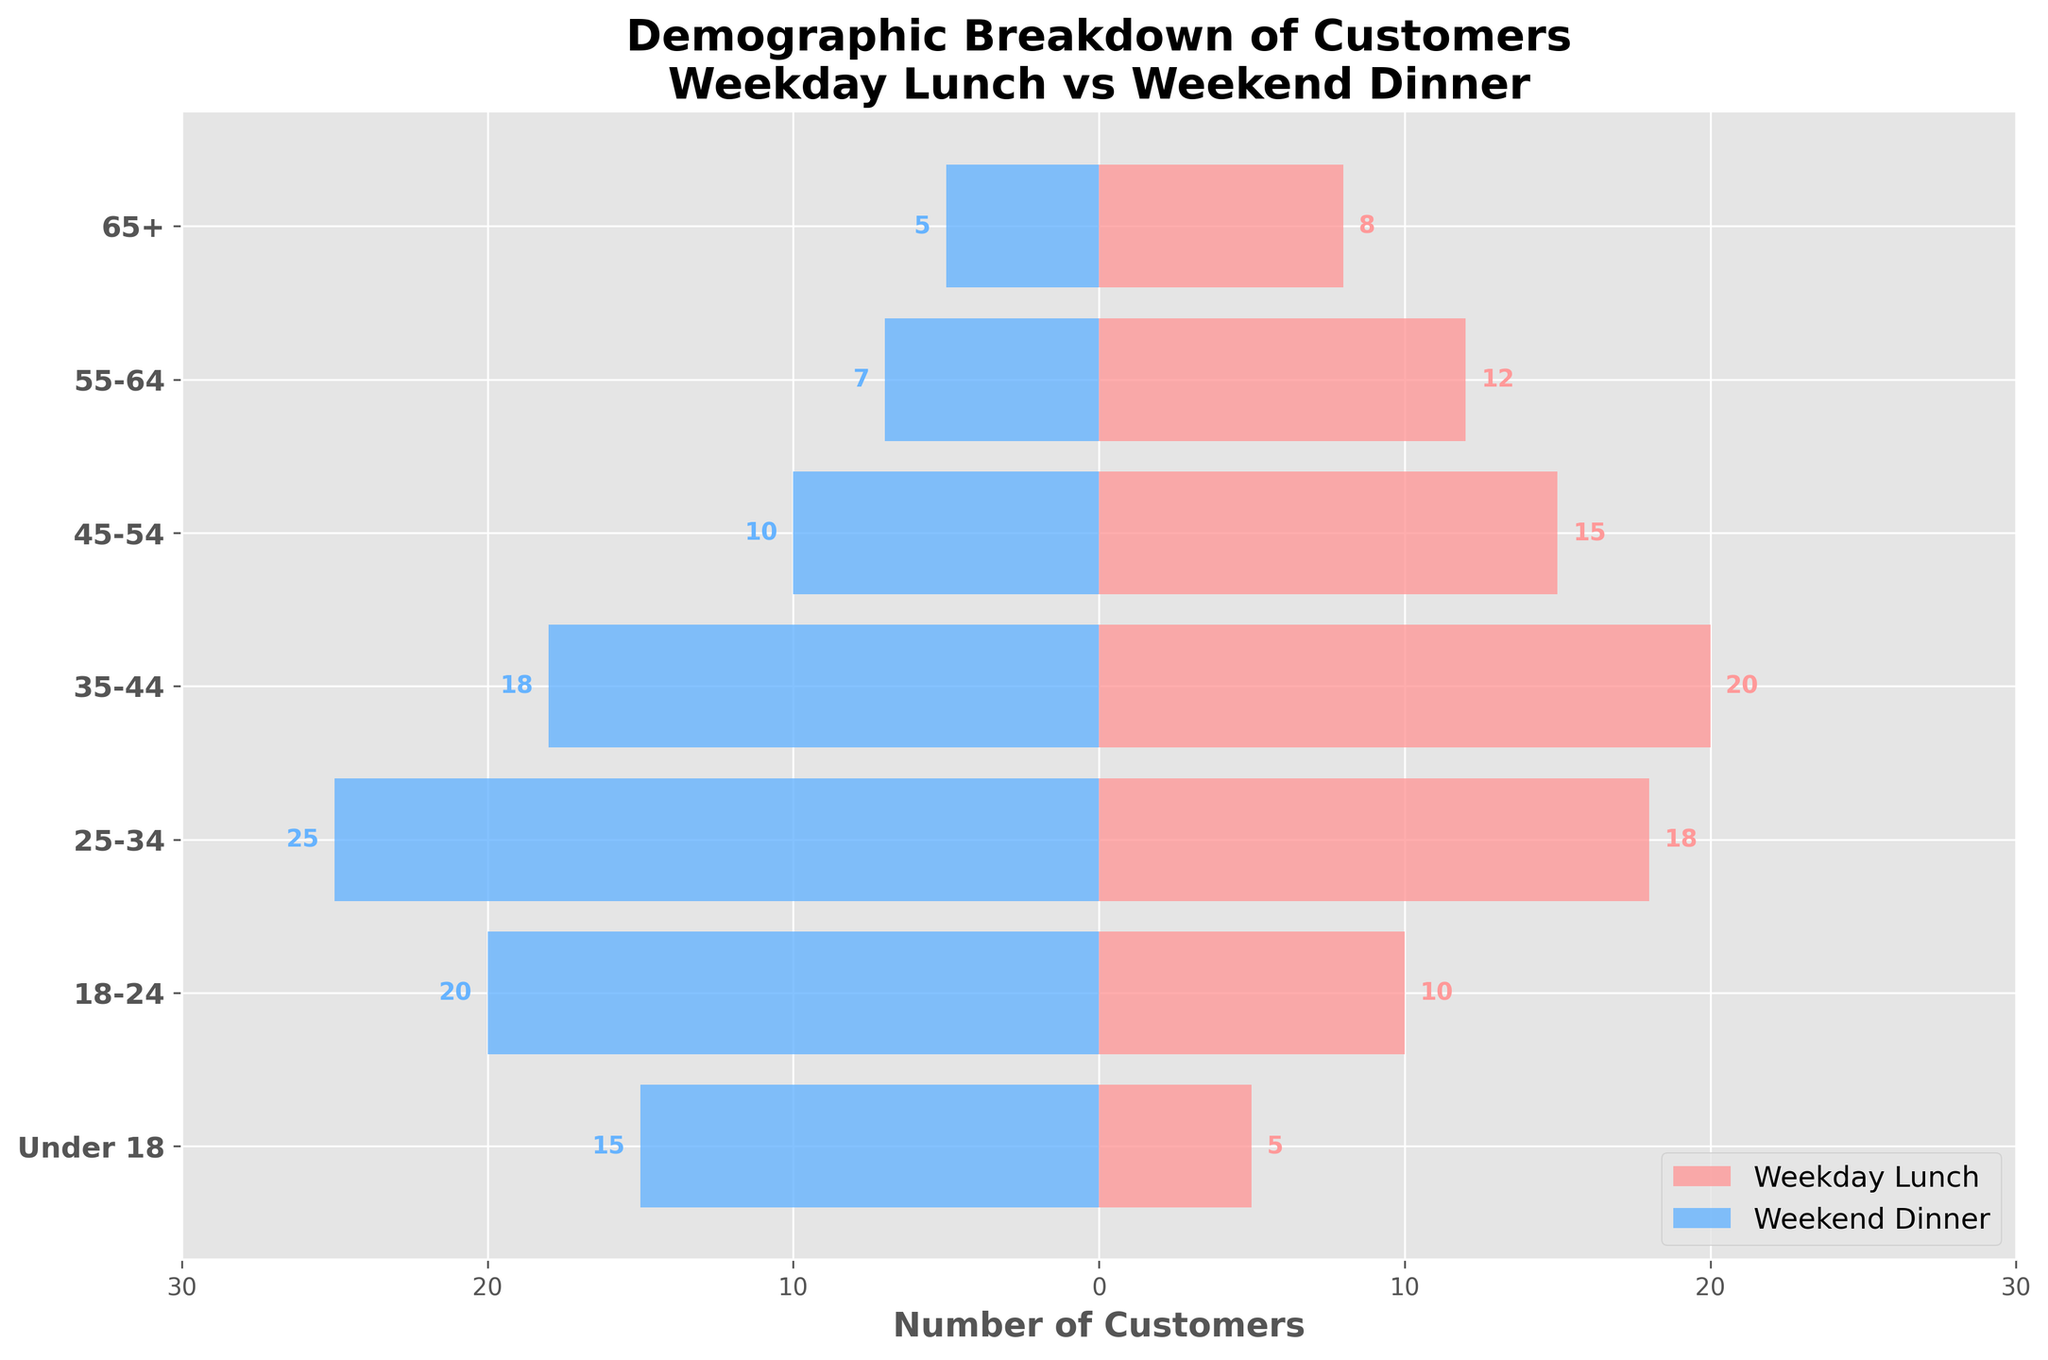What is the title of the figure? The title is presented at the top of the figure. It provides context for what the plot represents. The title is "Demographic Breakdown of Customers: Weekday Lunch vs Weekend Dinner."
Answer: Demographic Breakdown of Customers: Weekday Lunch vs Weekend Dinner Which age group has the highest number of customers during weekend dinners? By comparing the negative bars on the left side, we see which bar extends the furthest. The largest negative bar indicates the age group "25-34."
Answer: 25-34 What is the total number of customers for the 35-44 age group across both time periods? To find the total, sum the number of customers during weekday lunch and weekend dinner for the 35-44 age group. 20 (weekday lunch) + 18 (weekend dinner) = 38.
Answer: 38 How do the age groups "55-64" differ between weekday lunch and weekend dinner? Compare the lengths of bars for the two periods. For the 55-64 age group, the weekday lunch has 12 customers, and weekend dinner has 7 customers. The difference is 12 - 7 = 5 more customers during weekday lunch.
Answer: 5 more customers during weekday lunch What is the average number of customers for the "Under 18" age group across both periods? To calculate the average, add the customers for weekday lunch (5) and weekend dinner (15) and then divide by 2. (5 + 15) / 2 = 10.
Answer: 10 Which has a higher discrepancy in customer numbers between weekday lunch and weekend dinner: the "18-24" age group or the "45-54" age group? First, find the differences for both groups. For 18-24: 10 (weekday lunch) - 20 (weekend dinner) = -10. For 45-54: 15 (weekday lunch) - 10 (weekend dinner) = 5. The higher discrepancy is in the "18-24" age group.
Answer: 18-24 Is there any age group where the number of customers for weekday lunch equals that for weekend dinner? By checking the bars for both time periods, we see that no age group has an equal number of customers for both times.
Answer: No Which group has the smallest number of customers for weekday lunch? The smallest bar on the right side for weekday lunch represents the lowest number. It belongs to the "Under 18" age group, which has 5 customers.
Answer: Under 18 Does the "65+" age group see more customers during weekday lunch or weekend dinner? Compare the bars for the "65+" age group. Weekday lunch has 8 customers, and weekend dinner has 5 customers. Therefore, more customers come during weekday lunch.
Answer: Weekday lunch 